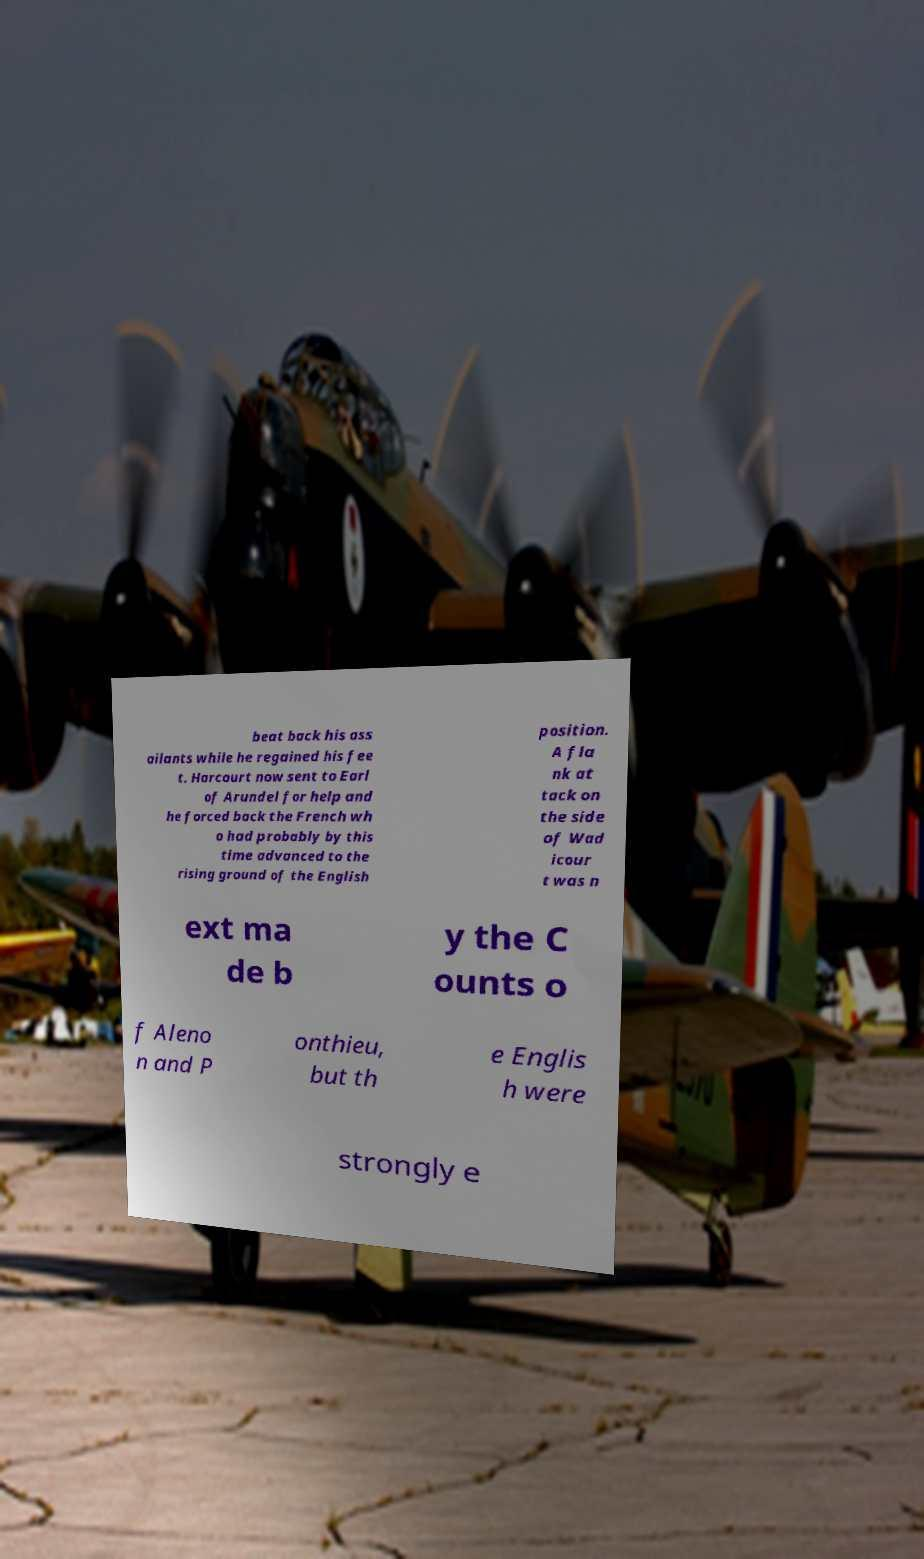I need the written content from this picture converted into text. Can you do that? beat back his ass ailants while he regained his fee t. Harcourt now sent to Earl of Arundel for help and he forced back the French wh o had probably by this time advanced to the rising ground of the English position. A fla nk at tack on the side of Wad icour t was n ext ma de b y the C ounts o f Aleno n and P onthieu, but th e Englis h were strongly e 